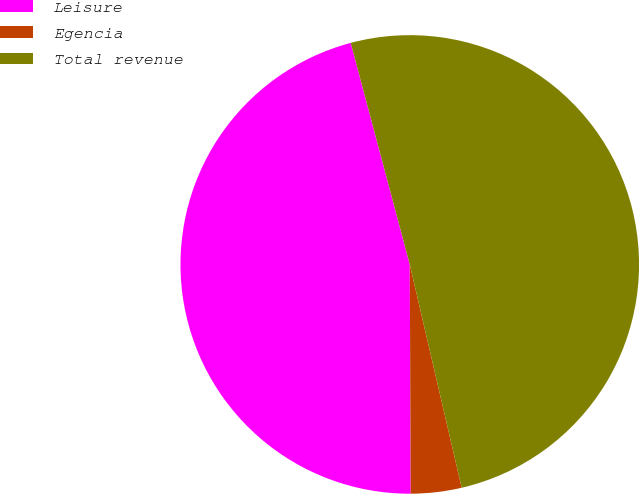Convert chart to OTSL. <chart><loc_0><loc_0><loc_500><loc_500><pie_chart><fcel>Leisure<fcel>Egencia<fcel>Total revenue<nl><fcel>45.92%<fcel>3.57%<fcel>50.51%<nl></chart> 